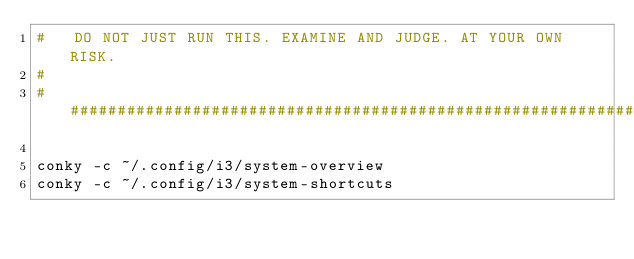Convert code to text. <code><loc_0><loc_0><loc_500><loc_500><_Bash_>#   DO NOT JUST RUN THIS. EXAMINE AND JUDGE. AT YOUR OWN RISK.
#
##################################################################################################################

conky -c ~/.config/i3/system-overview
conky -c ~/.config/i3/system-shortcuts</code> 